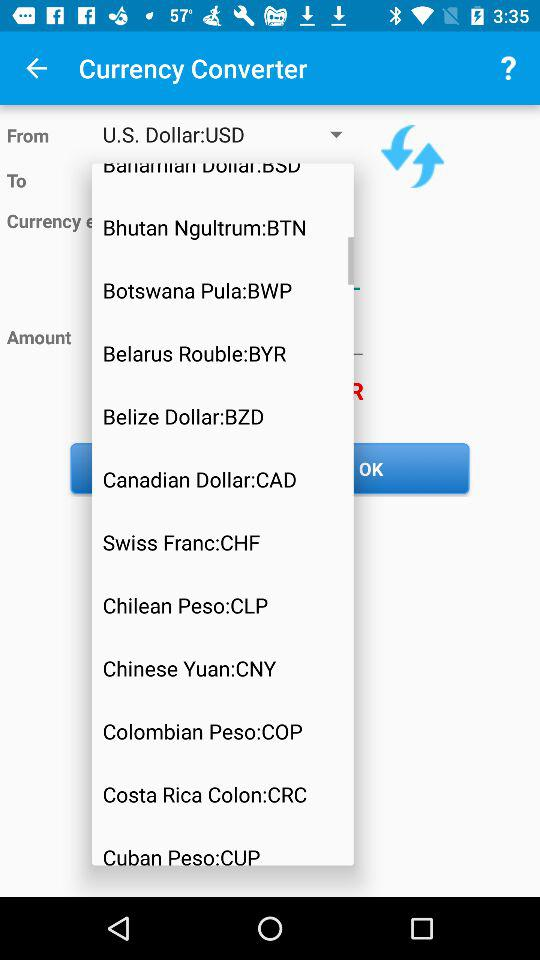Which currency is selected to convert? The currency is US dollars. 